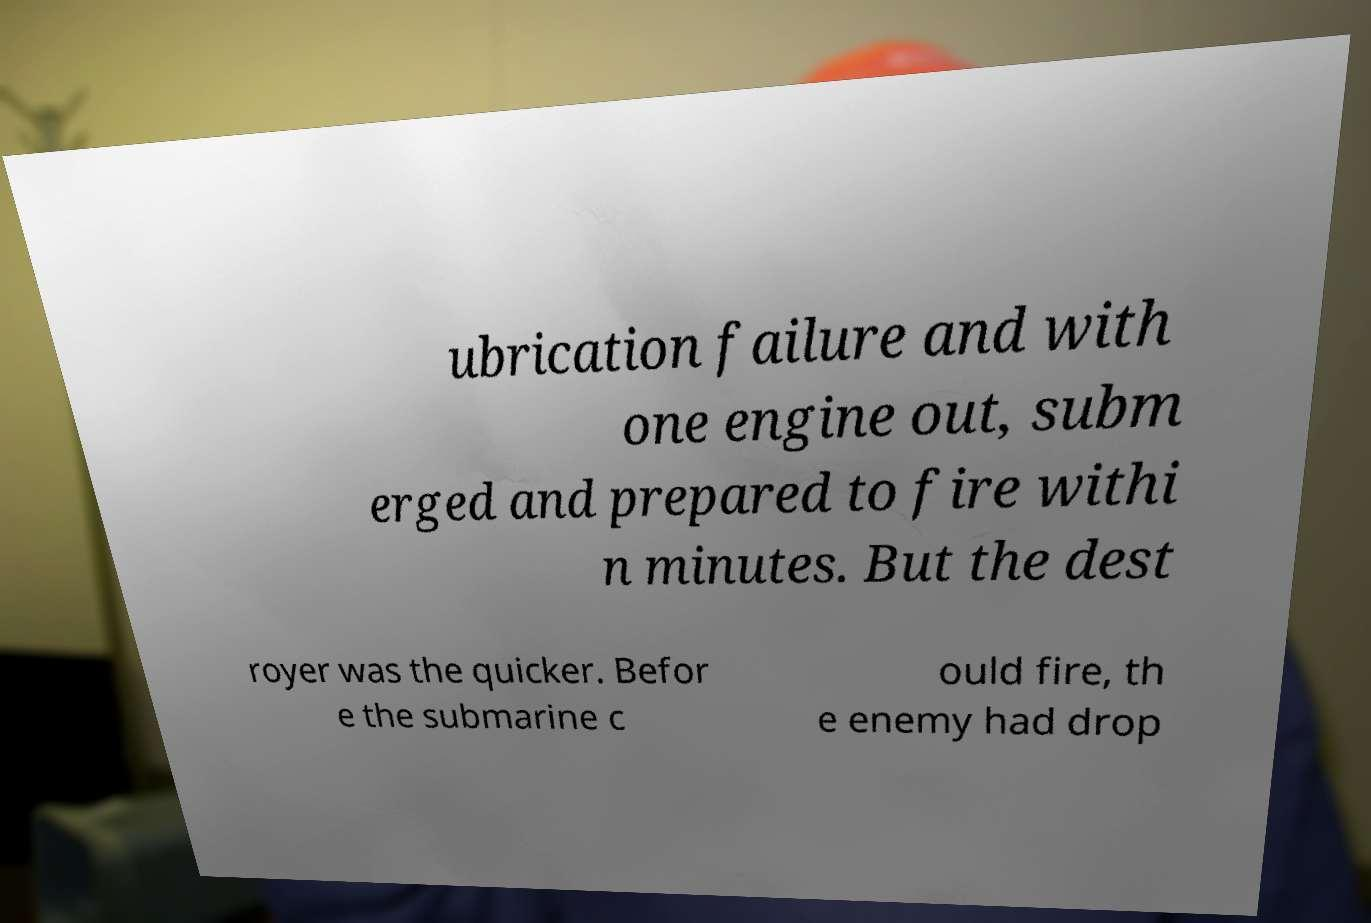I need the written content from this picture converted into text. Can you do that? ubrication failure and with one engine out, subm erged and prepared to fire withi n minutes. But the dest royer was the quicker. Befor e the submarine c ould fire, th e enemy had drop 